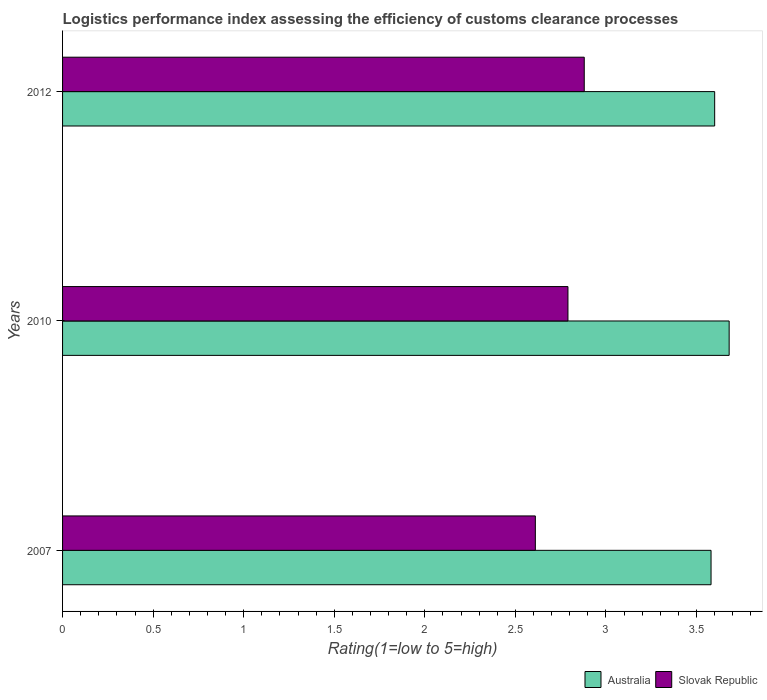How many groups of bars are there?
Offer a terse response. 3. Are the number of bars on each tick of the Y-axis equal?
Keep it short and to the point. Yes. How many bars are there on the 1st tick from the top?
Provide a succinct answer. 2. How many bars are there on the 2nd tick from the bottom?
Offer a very short reply. 2. What is the Logistic performance index in Australia in 2012?
Provide a short and direct response. 3.6. Across all years, what is the maximum Logistic performance index in Australia?
Offer a very short reply. 3.68. Across all years, what is the minimum Logistic performance index in Slovak Republic?
Make the answer very short. 2.61. What is the total Logistic performance index in Australia in the graph?
Keep it short and to the point. 10.86. What is the difference between the Logistic performance index in Slovak Republic in 2007 and that in 2012?
Your answer should be very brief. -0.27. What is the difference between the Logistic performance index in Slovak Republic in 2010 and the Logistic performance index in Australia in 2007?
Keep it short and to the point. -0.79. What is the average Logistic performance index in Australia per year?
Offer a very short reply. 3.62. In the year 2012, what is the difference between the Logistic performance index in Slovak Republic and Logistic performance index in Australia?
Ensure brevity in your answer.  -0.72. What is the ratio of the Logistic performance index in Australia in 2010 to that in 2012?
Make the answer very short. 1.02. Is the Logistic performance index in Australia in 2010 less than that in 2012?
Your answer should be very brief. No. What is the difference between the highest and the second highest Logistic performance index in Australia?
Your response must be concise. 0.08. What is the difference between the highest and the lowest Logistic performance index in Slovak Republic?
Keep it short and to the point. 0.27. In how many years, is the Logistic performance index in Australia greater than the average Logistic performance index in Australia taken over all years?
Offer a terse response. 1. Is the sum of the Logistic performance index in Australia in 2010 and 2012 greater than the maximum Logistic performance index in Slovak Republic across all years?
Your answer should be very brief. Yes. What does the 1st bar from the bottom in 2010 represents?
Make the answer very short. Australia. How many bars are there?
Offer a very short reply. 6. Are all the bars in the graph horizontal?
Make the answer very short. Yes. What is the difference between two consecutive major ticks on the X-axis?
Provide a short and direct response. 0.5. Are the values on the major ticks of X-axis written in scientific E-notation?
Your response must be concise. No. Does the graph contain any zero values?
Give a very brief answer. No. Does the graph contain grids?
Ensure brevity in your answer.  No. Where does the legend appear in the graph?
Give a very brief answer. Bottom right. How are the legend labels stacked?
Provide a short and direct response. Horizontal. What is the title of the graph?
Your answer should be compact. Logistics performance index assessing the efficiency of customs clearance processes. Does "Grenada" appear as one of the legend labels in the graph?
Ensure brevity in your answer.  No. What is the label or title of the X-axis?
Your answer should be very brief. Rating(1=low to 5=high). What is the Rating(1=low to 5=high) of Australia in 2007?
Your answer should be very brief. 3.58. What is the Rating(1=low to 5=high) in Slovak Republic in 2007?
Your answer should be compact. 2.61. What is the Rating(1=low to 5=high) in Australia in 2010?
Give a very brief answer. 3.68. What is the Rating(1=low to 5=high) in Slovak Republic in 2010?
Ensure brevity in your answer.  2.79. What is the Rating(1=low to 5=high) in Australia in 2012?
Give a very brief answer. 3.6. What is the Rating(1=low to 5=high) of Slovak Republic in 2012?
Your answer should be compact. 2.88. Across all years, what is the maximum Rating(1=low to 5=high) of Australia?
Your answer should be very brief. 3.68. Across all years, what is the maximum Rating(1=low to 5=high) of Slovak Republic?
Your answer should be very brief. 2.88. Across all years, what is the minimum Rating(1=low to 5=high) in Australia?
Give a very brief answer. 3.58. Across all years, what is the minimum Rating(1=low to 5=high) of Slovak Republic?
Offer a very short reply. 2.61. What is the total Rating(1=low to 5=high) in Australia in the graph?
Your answer should be compact. 10.86. What is the total Rating(1=low to 5=high) in Slovak Republic in the graph?
Keep it short and to the point. 8.28. What is the difference between the Rating(1=low to 5=high) in Slovak Republic in 2007 and that in 2010?
Your answer should be compact. -0.18. What is the difference between the Rating(1=low to 5=high) of Australia in 2007 and that in 2012?
Provide a succinct answer. -0.02. What is the difference between the Rating(1=low to 5=high) of Slovak Republic in 2007 and that in 2012?
Your answer should be very brief. -0.27. What is the difference between the Rating(1=low to 5=high) of Australia in 2010 and that in 2012?
Offer a very short reply. 0.08. What is the difference between the Rating(1=low to 5=high) of Slovak Republic in 2010 and that in 2012?
Offer a very short reply. -0.09. What is the difference between the Rating(1=low to 5=high) in Australia in 2007 and the Rating(1=low to 5=high) in Slovak Republic in 2010?
Make the answer very short. 0.79. What is the difference between the Rating(1=low to 5=high) of Australia in 2007 and the Rating(1=low to 5=high) of Slovak Republic in 2012?
Give a very brief answer. 0.7. What is the difference between the Rating(1=low to 5=high) of Australia in 2010 and the Rating(1=low to 5=high) of Slovak Republic in 2012?
Provide a succinct answer. 0.8. What is the average Rating(1=low to 5=high) in Australia per year?
Ensure brevity in your answer.  3.62. What is the average Rating(1=low to 5=high) of Slovak Republic per year?
Give a very brief answer. 2.76. In the year 2007, what is the difference between the Rating(1=low to 5=high) in Australia and Rating(1=low to 5=high) in Slovak Republic?
Keep it short and to the point. 0.97. In the year 2010, what is the difference between the Rating(1=low to 5=high) in Australia and Rating(1=low to 5=high) in Slovak Republic?
Keep it short and to the point. 0.89. In the year 2012, what is the difference between the Rating(1=low to 5=high) in Australia and Rating(1=low to 5=high) in Slovak Republic?
Your response must be concise. 0.72. What is the ratio of the Rating(1=low to 5=high) in Australia in 2007 to that in 2010?
Provide a short and direct response. 0.97. What is the ratio of the Rating(1=low to 5=high) in Slovak Republic in 2007 to that in 2010?
Offer a terse response. 0.94. What is the ratio of the Rating(1=low to 5=high) in Australia in 2007 to that in 2012?
Provide a short and direct response. 0.99. What is the ratio of the Rating(1=low to 5=high) in Slovak Republic in 2007 to that in 2012?
Your answer should be compact. 0.91. What is the ratio of the Rating(1=low to 5=high) of Australia in 2010 to that in 2012?
Make the answer very short. 1.02. What is the ratio of the Rating(1=low to 5=high) of Slovak Republic in 2010 to that in 2012?
Offer a very short reply. 0.97. What is the difference between the highest and the second highest Rating(1=low to 5=high) of Australia?
Your response must be concise. 0.08. What is the difference between the highest and the second highest Rating(1=low to 5=high) of Slovak Republic?
Provide a short and direct response. 0.09. What is the difference between the highest and the lowest Rating(1=low to 5=high) in Australia?
Keep it short and to the point. 0.1. What is the difference between the highest and the lowest Rating(1=low to 5=high) of Slovak Republic?
Provide a succinct answer. 0.27. 